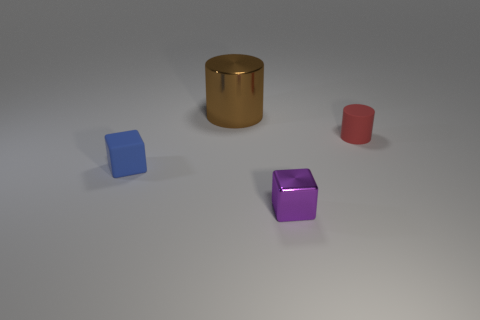Is there anything else that is the same shape as the blue object?
Your response must be concise. Yes. There is a small rubber object that is the same shape as the tiny purple metal object; what is its color?
Keep it short and to the point. Blue. There is a small cube that is behind the tiny purple cube; what is it made of?
Ensure brevity in your answer.  Rubber. The tiny metal object has what color?
Your answer should be compact. Purple. There is a cylinder on the left side of the red rubber cylinder; is its size the same as the small red thing?
Keep it short and to the point. No. There is a cylinder on the left side of the matte thing that is to the right of the block that is to the right of the blue matte thing; what is its material?
Your response must be concise. Metal. There is a small block on the left side of the tiny metallic object; is it the same color as the cylinder behind the small red object?
Provide a short and direct response. No. There is a small thing that is behind the cube on the left side of the brown object; what is its material?
Provide a short and direct response. Rubber. The block that is the same size as the purple thing is what color?
Your answer should be compact. Blue. Does the tiny blue matte object have the same shape as the red thing in front of the big brown metallic thing?
Your answer should be very brief. No. 